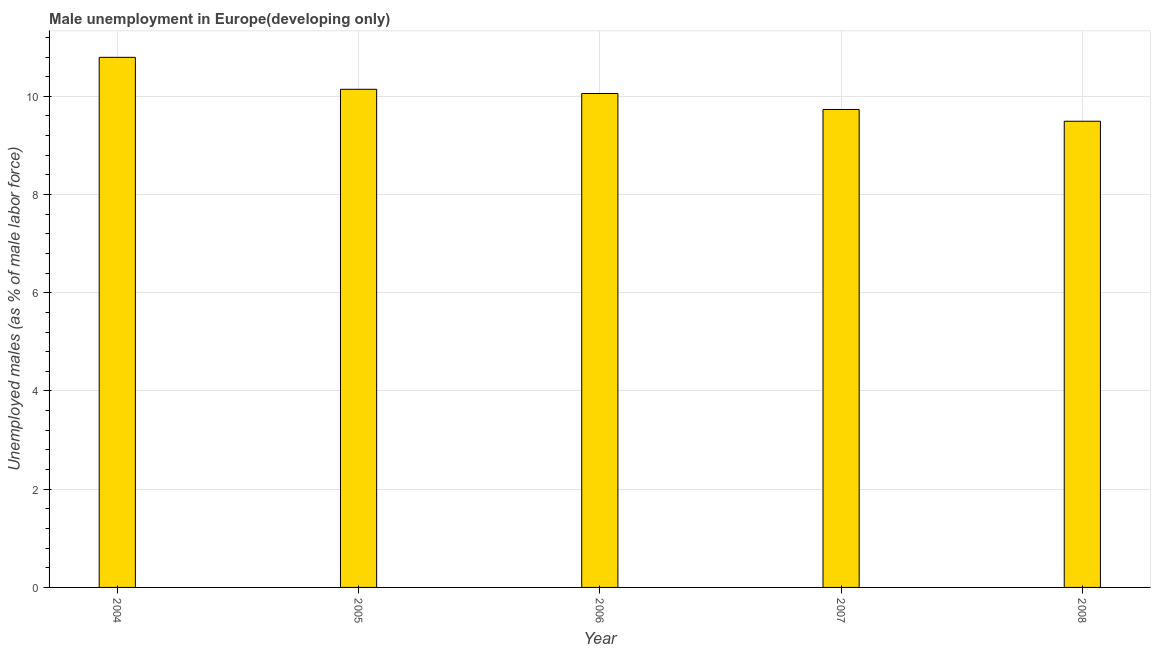Does the graph contain any zero values?
Your answer should be very brief. No. Does the graph contain grids?
Keep it short and to the point. Yes. What is the title of the graph?
Provide a succinct answer. Male unemployment in Europe(developing only). What is the label or title of the X-axis?
Make the answer very short. Year. What is the label or title of the Y-axis?
Provide a succinct answer. Unemployed males (as % of male labor force). What is the unemployed males population in 2004?
Give a very brief answer. 10.79. Across all years, what is the maximum unemployed males population?
Your response must be concise. 10.79. Across all years, what is the minimum unemployed males population?
Keep it short and to the point. 9.49. What is the sum of the unemployed males population?
Provide a succinct answer. 50.22. What is the difference between the unemployed males population in 2004 and 2008?
Keep it short and to the point. 1.3. What is the average unemployed males population per year?
Your response must be concise. 10.04. What is the median unemployed males population?
Provide a succinct answer. 10.06. Do a majority of the years between 2008 and 2006 (inclusive) have unemployed males population greater than 5.6 %?
Offer a very short reply. Yes. What is the ratio of the unemployed males population in 2006 to that in 2007?
Give a very brief answer. 1.03. What is the difference between the highest and the second highest unemployed males population?
Make the answer very short. 0.65. What is the difference between the highest and the lowest unemployed males population?
Keep it short and to the point. 1.3. How many bars are there?
Offer a terse response. 5. What is the difference between two consecutive major ticks on the Y-axis?
Provide a succinct answer. 2. What is the Unemployed males (as % of male labor force) of 2004?
Provide a short and direct response. 10.79. What is the Unemployed males (as % of male labor force) of 2005?
Your answer should be compact. 10.14. What is the Unemployed males (as % of male labor force) of 2006?
Your response must be concise. 10.06. What is the Unemployed males (as % of male labor force) in 2007?
Provide a short and direct response. 9.73. What is the Unemployed males (as % of male labor force) in 2008?
Your response must be concise. 9.49. What is the difference between the Unemployed males (as % of male labor force) in 2004 and 2005?
Provide a short and direct response. 0.65. What is the difference between the Unemployed males (as % of male labor force) in 2004 and 2006?
Offer a terse response. 0.74. What is the difference between the Unemployed males (as % of male labor force) in 2004 and 2007?
Provide a succinct answer. 1.06. What is the difference between the Unemployed males (as % of male labor force) in 2004 and 2008?
Your answer should be compact. 1.3. What is the difference between the Unemployed males (as % of male labor force) in 2005 and 2006?
Provide a short and direct response. 0.09. What is the difference between the Unemployed males (as % of male labor force) in 2005 and 2007?
Your answer should be compact. 0.41. What is the difference between the Unemployed males (as % of male labor force) in 2005 and 2008?
Offer a very short reply. 0.65. What is the difference between the Unemployed males (as % of male labor force) in 2006 and 2007?
Provide a short and direct response. 0.33. What is the difference between the Unemployed males (as % of male labor force) in 2006 and 2008?
Your response must be concise. 0.57. What is the difference between the Unemployed males (as % of male labor force) in 2007 and 2008?
Make the answer very short. 0.24. What is the ratio of the Unemployed males (as % of male labor force) in 2004 to that in 2005?
Give a very brief answer. 1.06. What is the ratio of the Unemployed males (as % of male labor force) in 2004 to that in 2006?
Keep it short and to the point. 1.07. What is the ratio of the Unemployed males (as % of male labor force) in 2004 to that in 2007?
Provide a short and direct response. 1.11. What is the ratio of the Unemployed males (as % of male labor force) in 2004 to that in 2008?
Offer a terse response. 1.14. What is the ratio of the Unemployed males (as % of male labor force) in 2005 to that in 2007?
Offer a very short reply. 1.04. What is the ratio of the Unemployed males (as % of male labor force) in 2005 to that in 2008?
Your answer should be compact. 1.07. What is the ratio of the Unemployed males (as % of male labor force) in 2006 to that in 2007?
Keep it short and to the point. 1.03. What is the ratio of the Unemployed males (as % of male labor force) in 2006 to that in 2008?
Your answer should be compact. 1.06. What is the ratio of the Unemployed males (as % of male labor force) in 2007 to that in 2008?
Your answer should be compact. 1.02. 